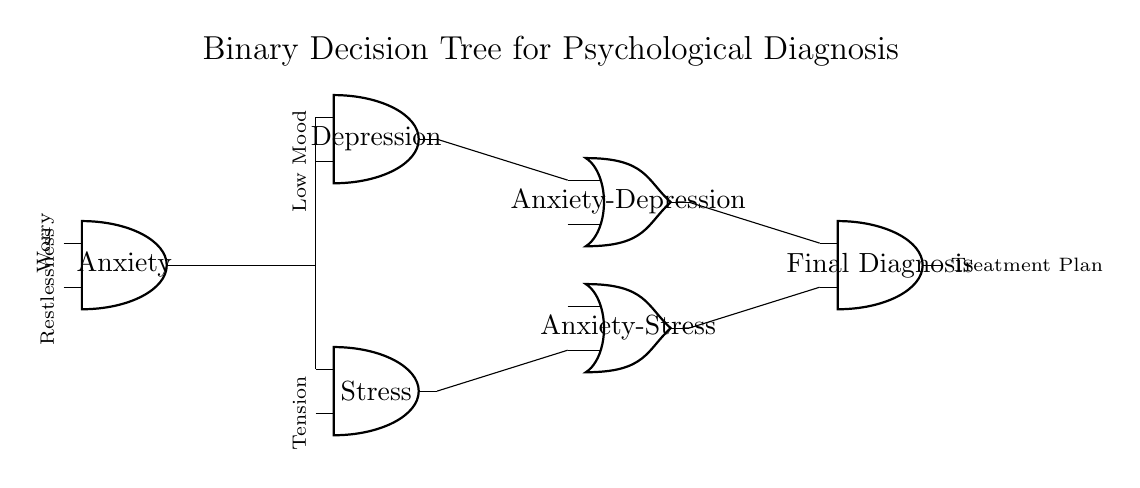What is the output of the final diagnosis node? The output of the final diagnosis node indicates the culmination of the decision tree's evaluation. In this circuit, it leads to a treatment plan based on the preceding assessments of anxiety, depression, and stress.
Answer: Treatment Plan How many decision nodes are present in the circuit? The circuit contains three decision nodes: Anxiety, Depression, and Stress, which are used to evaluate different mental health parameters.
Answer: Three What type of gate is used to combine the Anxiety and Depression outputs? The gate used to combine the outputs from the Anxiety and Depression nodes is an OR gate, which signifies that either of the conditions can lead to the subsequent output.
Answer: OR gate What are the input parameters of the Anxiety node? The input parameters for the Anxiety node are Worry and Restlessness, which serve as indicators for the assessment of anxiety levels.
Answer: Worry, Restlessness Which outputs connect to the final diagnosis node? The outputs connecting to the final diagnosis node are Anxiety-Depression and Anxiety-Stress, indicating the combined effects of these mental health conditions before arriving at the final diagnosis.
Answer: Anxiety-Depression, Anxiety-Stress What is the purpose of the stress node in the circuit? The purpose of the stress node is to evaluate an individual's levels of tension, which can contribute to the overall diagnosis of mental health conditions along with anxiety and depression.
Answer: Evaluate tension Which conditions lead to the Anxiety-Depression output? The conditions leading to the Anxiety-Depression output are Anxiety and Depression, establishing that both must be assessed to arrive at this combination diagnosis.
Answer: Anxiety, Depression 